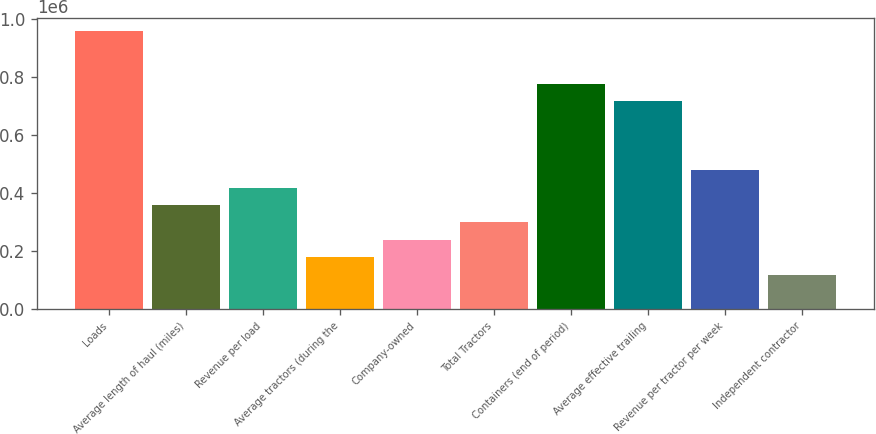Convert chart. <chart><loc_0><loc_0><loc_500><loc_500><bar_chart><fcel>Loads<fcel>Average length of haul (miles)<fcel>Revenue per load<fcel>Average tractors (during the<fcel>Company-owned<fcel>Total Tractors<fcel>Containers (end of period)<fcel>Average effective trailing<fcel>Revenue per tractor per week<fcel>Independent contractor<nl><fcel>958134<fcel>359339<fcel>419218<fcel>179700<fcel>239580<fcel>299460<fcel>778496<fcel>718616<fcel>479098<fcel>119821<nl></chart> 